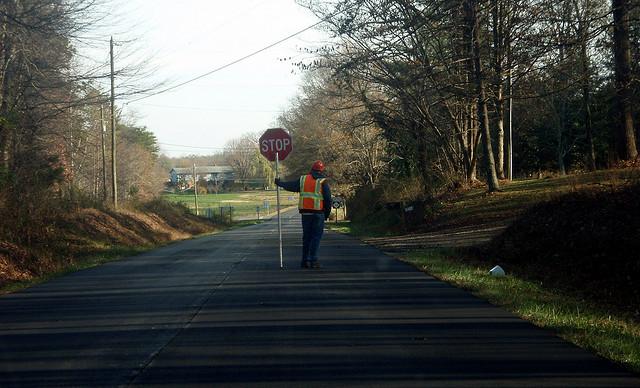Does the grass need to be mowed?
Be succinct. No. What does the sign say?
Answer briefly. Stop. What is the woman holding up to her head?
Be succinct. Stop sign. Where is the litter?
Write a very short answer. Side of road. What is the man holding?
Quick response, please. Stop sign. 